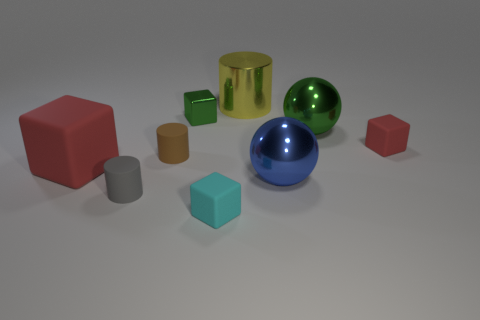Subtract all blocks. How many objects are left? 5 Subtract 0 blue cylinders. How many objects are left? 9 Subtract all big yellow shiny things. Subtract all tiny matte cylinders. How many objects are left? 6 Add 3 big green objects. How many big green objects are left? 4 Add 6 green metallic spheres. How many green metallic spheres exist? 7 